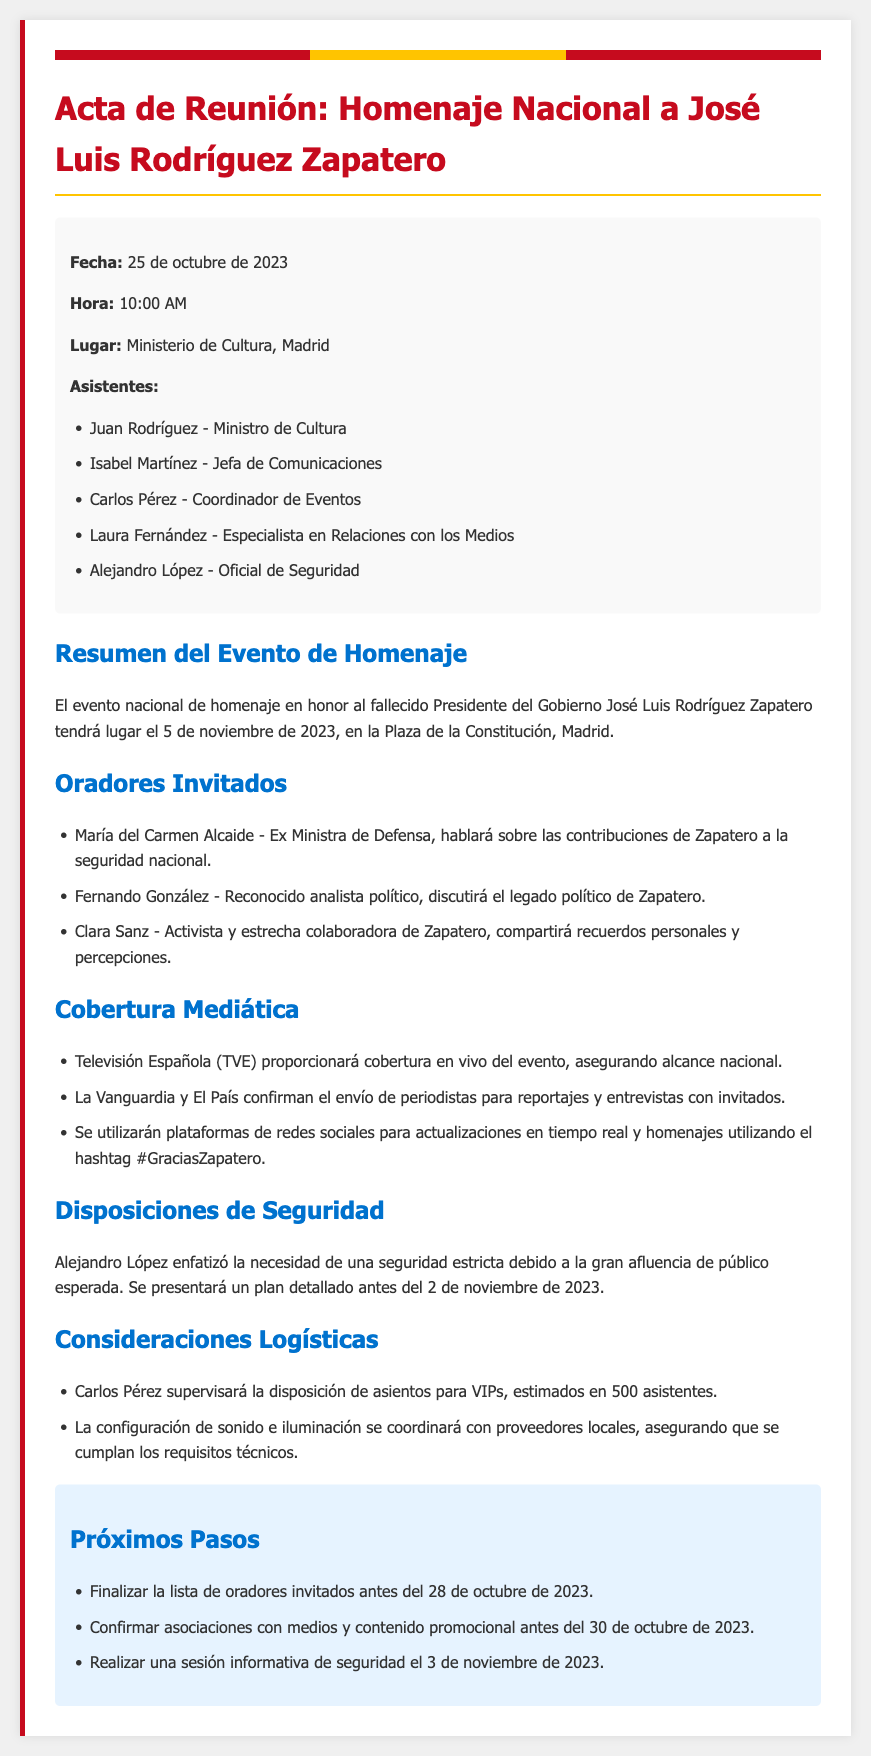¿Cuándo se llevará a cabo el evento de homenaje? El evento tendrá lugar el 5 de noviembre de 2023, según el resumen del evento.
Answer: 5 de noviembre de 2023 ¿Quién es el Ministro de Cultura que asistió a la reunión? La lista de asistentes menciona a Juan Rodríguez como el Ministro de Cultura.
Answer: Juan Rodríguez ¿Cuáles medios proveerán cobertura en vivo del evento? La sección de cobertura mediática indica que Televisión Española (TVE) proporcionará cobertura en vivo.
Answer: Televisión Española (TVE) ¿Cuántos oradores invitados hay? Se enumeran tres oradores invitados en el documento.
Answer: Tres ¿Qué se realizará el 3 de noviembre de 2023? En los próximos pasos, se menciona que se realizará una sesión informativa de seguridad.
Answer: Sesión informativa de seguridad ¿Cuál es el hashtag para el homenaje en redes sociales? El documento menciona que el hashtag utilizado será #GraciasZapatero.
Answer: #GraciasZapatero ¿Quién coordinará la disposición de asientos para VIPs? Carlos Pérez es mencionado como el responsable de supervisar la disposición de asientos.
Answer: Carlos Pérez ¿Cuántos asistentes VIP se estiman? En las consideraciones logísticas se indica que se estiman en 500 asistentes VIP.
Answer: 500 asistentes 